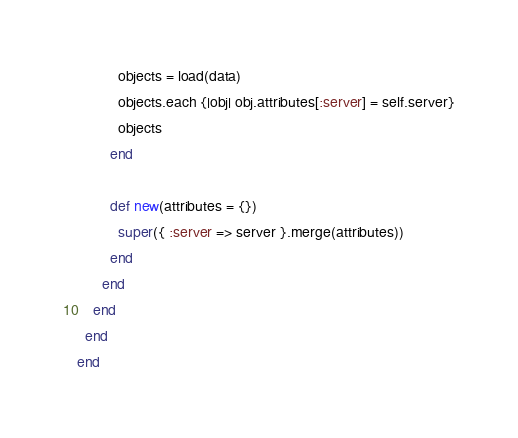Convert code to text. <code><loc_0><loc_0><loc_500><loc_500><_Ruby_>          objects = load(data)
          objects.each {|obj| obj.attributes[:server] = self.server}
          objects
        end

        def new(attributes = {})
          super({ :server => server }.merge(attributes))
        end
      end
    end
  end
end
</code> 